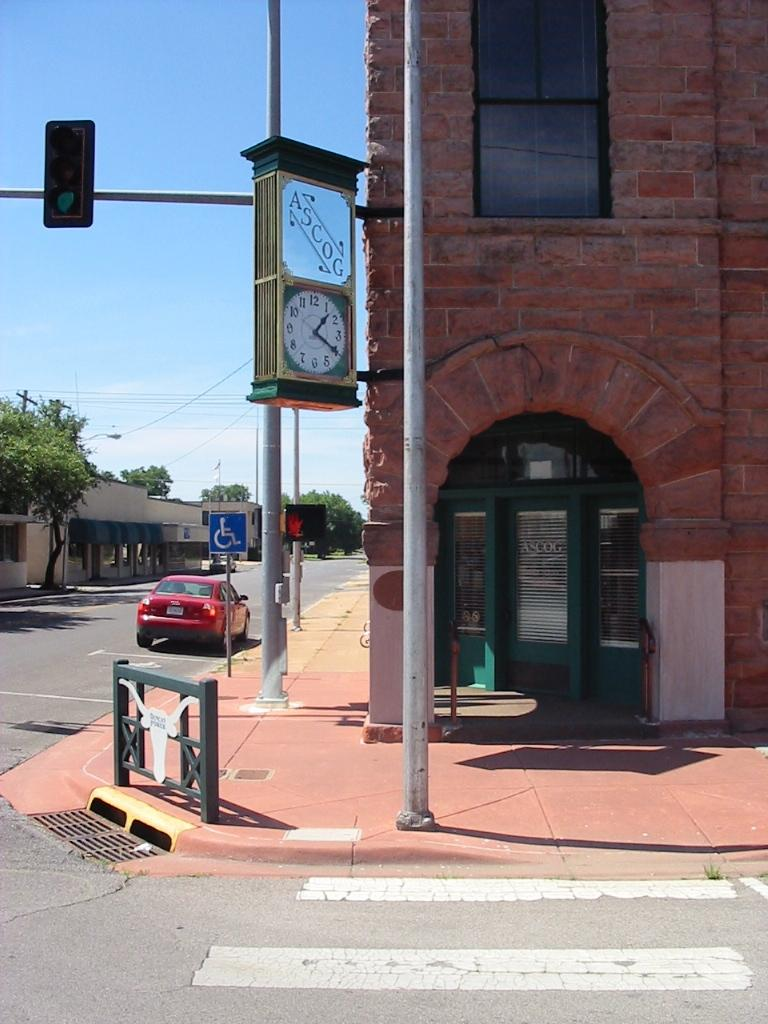<image>
Create a compact narrative representing the image presented. The outside of a building at a street corner with a clock and ASCOG sign. 